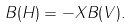<formula> <loc_0><loc_0><loc_500><loc_500>B ( H ) = - X B ( V ) .</formula> 